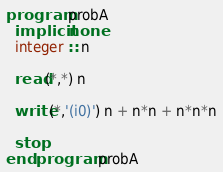Convert code to text. <code><loc_0><loc_0><loc_500><loc_500><_FORTRAN_>program probA
  implicit none
  integer :: n

  read(*,*) n

  write(*,'(i0)') n + n*n + n*n*n
  
  stop
end program probA
</code> 